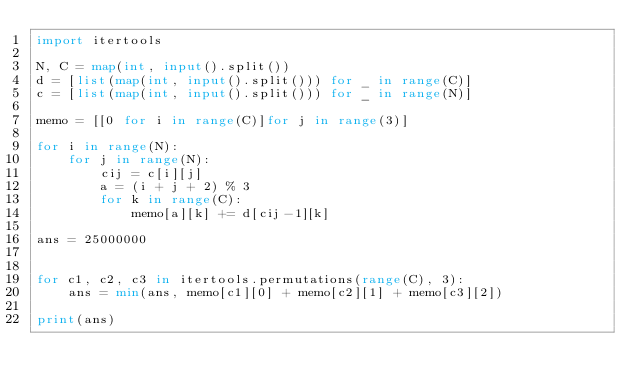Convert code to text. <code><loc_0><loc_0><loc_500><loc_500><_Python_>import itertools

N, C = map(int, input().split())
d = [list(map(int, input().split())) for _ in range(C)]
c = [list(map(int, input().split())) for _ in range(N)]

memo = [[0 for i in range(C)]for j in range(3)]

for i in range(N):
    for j in range(N):
        cij = c[i][j]
        a = (i + j + 2) % 3
        for k in range(C):
            memo[a][k] += d[cij-1][k]

ans = 25000000


for c1, c2, c3 in itertools.permutations(range(C), 3):
    ans = min(ans, memo[c1][0] + memo[c2][1] + memo[c3][2])

print(ans)</code> 